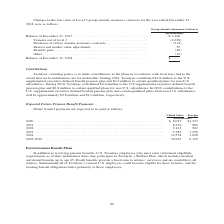According to Teradyne's financial document, What is the Expected Future Pension Benefit Payments in 2020 under United States? According to the financial document, $8,027 (in thousands). The relevant text states: "(in thousands) 2020 . $ 8,027 $1,237 2021 . 8,416 985 2022 . 9,163 982 2023 . 9,785 1,258 2024 . 10,558 1,098 2025-2029 . 59,665..." Also, In which regions would future benefit payments be expected to be paid? The document shows two values: United States and Foreign. From the document: "United States Foreign United States Foreign..." Also, What is the payment for  2025-2029 for Foreign? According to the financial document, 6,129 (in thousands). The relevant text states: ",785 1,258 2024 . 10,558 1,098 2025-2029 . 59,665 6,129..." Also, can you calculate: What is the difference in payment for United States and Foreign for 2020? Based on the calculation: 8,027-1,237, the result is 6790 (in thousands). This is based on the information: "(in thousands) 2020 . $ 8,027 $1,237 2021 . 8,416 985 2022 . 9,163 982 2023 . 9,785 1,258 2024 . 10,558 1,098 2025-2029 . 59,665 (in thousands) 2020 . $ 8,027 $1,237 2021 . 8,416 985 2022 . 9,163 982 ..." The key data points involved are: 1,237, 8,027. Also, can you calculate: What would the change in Expected Future Pension Benefit Payments under the United States in 2022 from 2021 be? Based on the calculation: 9,163-8,416, the result is 747 (in thousands). This is based on the information: "(in thousands) 2020 . $ 8,027 $1,237 2021 . 8,416 985 2022 . 9,163 982 2023 . 9,785 1,258 2024 . 10,558 1,098 2025-2029 . 59,665 6,129 ds) 2020 . $ 8,027 $1,237 2021 . 8,416 985 2022 . 9,163 982 2023 ..." The key data points involved are: 8,416, 9,163. Also, can you calculate: What would the percentage change in Expected Future Pension Benefit Payments under the United States in 2022 from 2021 be? To answer this question, I need to perform calculations using the financial data. The calculation is: (9,163-8,416)/8,416, which equals 8.88 (percentage). This is based on the information: "(in thousands) 2020 . $ 8,027 $1,237 2021 . 8,416 985 2022 . 9,163 982 2023 . 9,785 1,258 2024 . 10,558 1,098 2025-2029 . 59,665 6,129 ds) 2020 . $ 8,027 $1,237 2021 . 8,416 985 2022 . 9,163 982 2023 ..." The key data points involved are: 8,416, 9,163. 